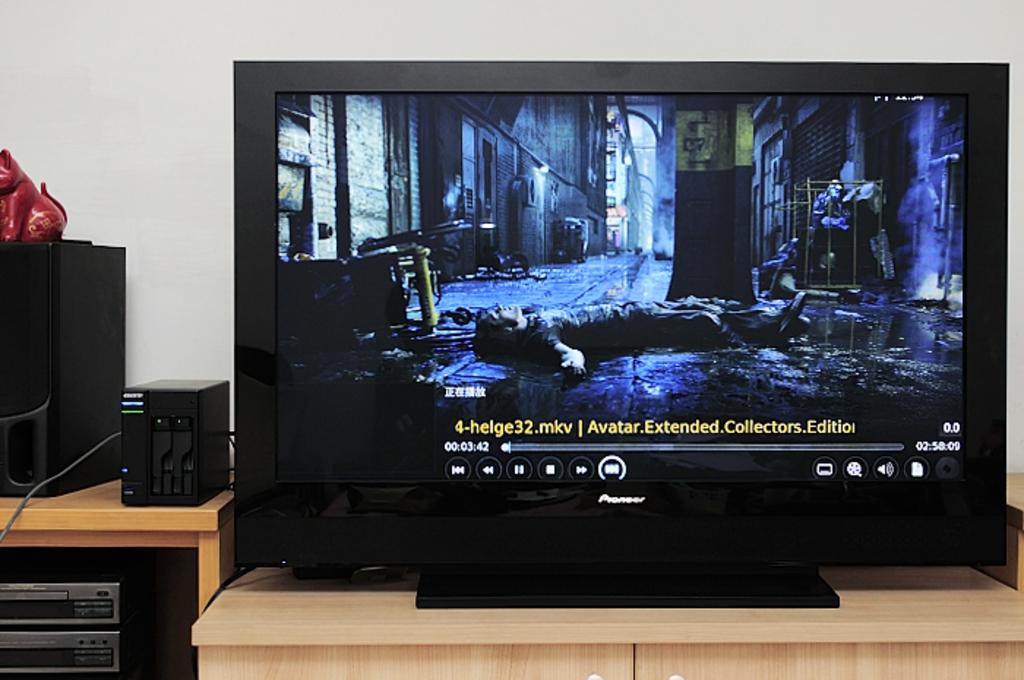<image>
Relay a brief, clear account of the picture shown. A large TV with Avatar Extended Collectors Edition on it 